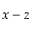Convert formula to latex. <formula><loc_0><loc_0><loc_500><loc_500>x - z</formula> 